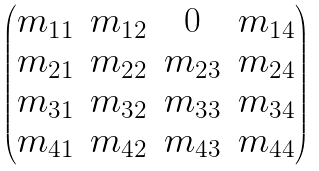Convert formula to latex. <formula><loc_0><loc_0><loc_500><loc_500>\begin{pmatrix} m _ { 1 1 } & m _ { 1 2 } & 0 & m _ { 1 4 } \\ m _ { 2 1 } & m _ { 2 2 } & m _ { 2 3 } & m _ { 2 4 } \\ m _ { 3 1 } & m _ { 3 2 } & m _ { 3 3 } & m _ { 3 4 } \\ m _ { 4 1 } & m _ { 4 2 } & m _ { 4 3 } & m _ { 4 4 } \end{pmatrix}</formula> 